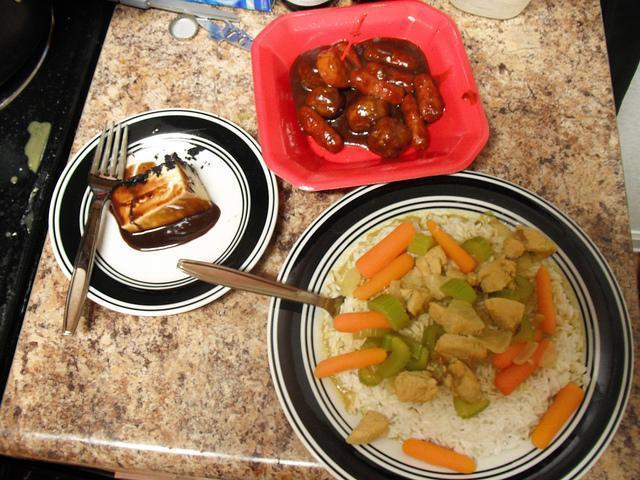How many different foods are there?
Give a very brief answer. 3. How many forks are in the picture?
Give a very brief answer. 2. How many windows on this airplane are touched by red or orange paint?
Give a very brief answer. 0. 